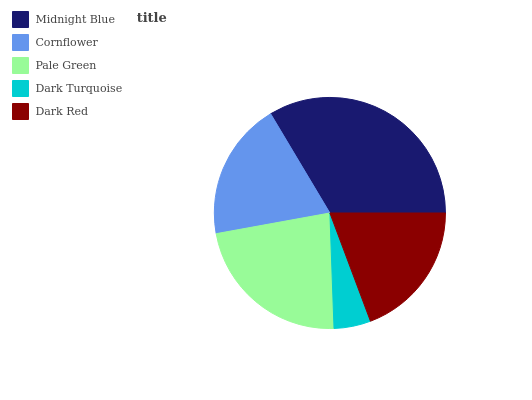Is Dark Turquoise the minimum?
Answer yes or no. Yes. Is Midnight Blue the maximum?
Answer yes or no. Yes. Is Cornflower the minimum?
Answer yes or no. No. Is Cornflower the maximum?
Answer yes or no. No. Is Midnight Blue greater than Cornflower?
Answer yes or no. Yes. Is Cornflower less than Midnight Blue?
Answer yes or no. Yes. Is Cornflower greater than Midnight Blue?
Answer yes or no. No. Is Midnight Blue less than Cornflower?
Answer yes or no. No. Is Dark Red the high median?
Answer yes or no. Yes. Is Dark Red the low median?
Answer yes or no. Yes. Is Pale Green the high median?
Answer yes or no. No. Is Cornflower the low median?
Answer yes or no. No. 